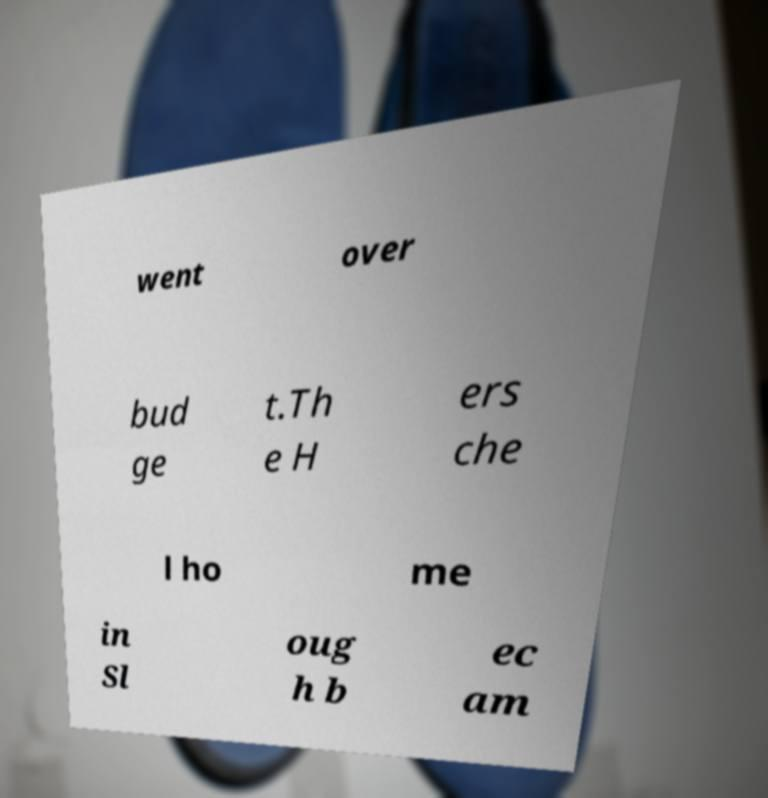What messages or text are displayed in this image? I need them in a readable, typed format. went over bud ge t.Th e H ers che l ho me in Sl oug h b ec am 